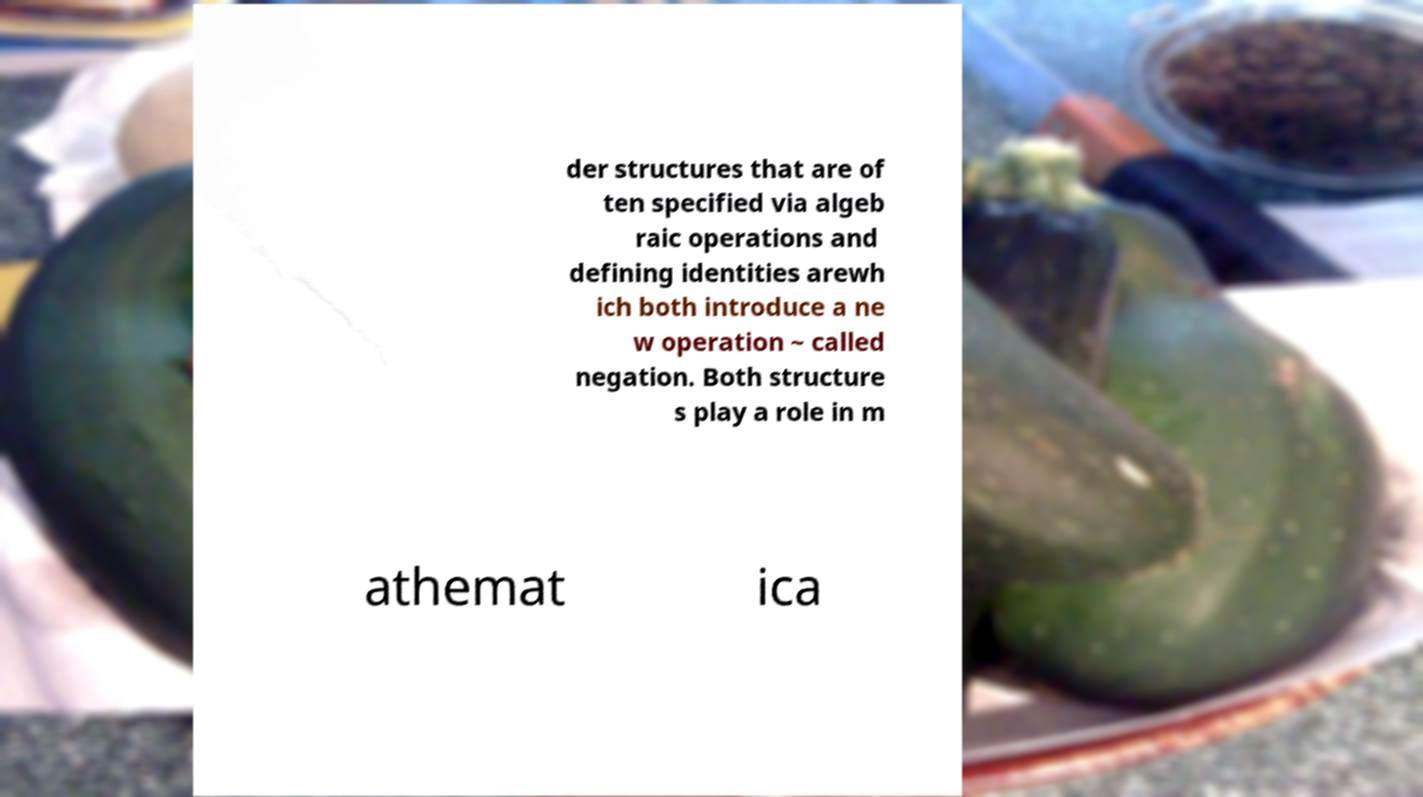There's text embedded in this image that I need extracted. Can you transcribe it verbatim? der structures that are of ten specified via algeb raic operations and defining identities arewh ich both introduce a ne w operation ~ called negation. Both structure s play a role in m athemat ica 